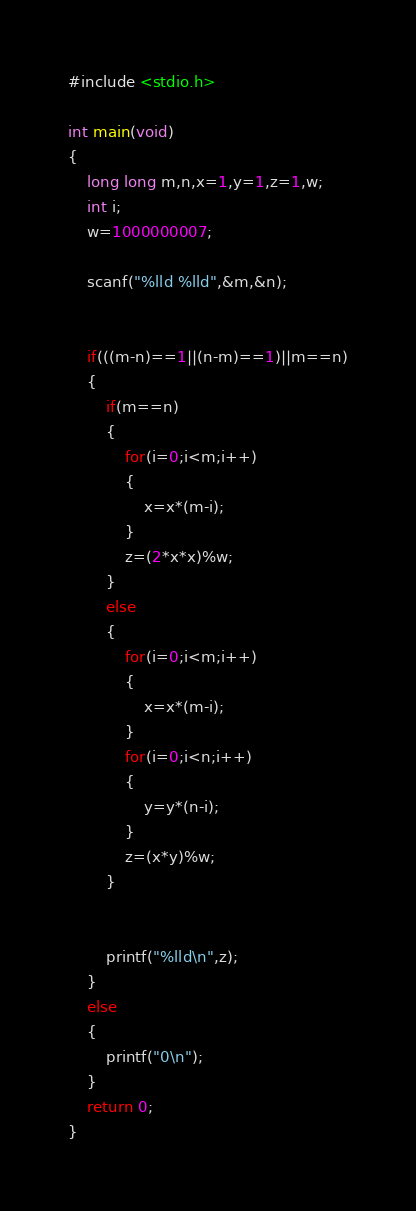Convert code to text. <code><loc_0><loc_0><loc_500><loc_500><_C_>#include <stdio.h>

int main(void)
{
    long long m,n,x=1,y=1,z=1,w;
    int i;
    w=1000000007;
    
    scanf("%lld %lld",&m,&n);
    
    
    if(((m-n)==1||(n-m)==1)||m==n)
    {
        if(m==n)
        {
            for(i=0;i<m;i++)
            {
                x=x*(m-i);
            }
            z=(2*x*x)%w;
        }
        else
        {
            for(i=0;i<m;i++)
            {
                x=x*(m-i);
            }
            for(i=0;i<n;i++)
            {
                y=y*(n-i);
            }
            z=(x*y)%w;
        }
        
        
        printf("%lld\n",z);
    }
    else
    {
        printf("0\n");
    }
    return 0;
}</code> 